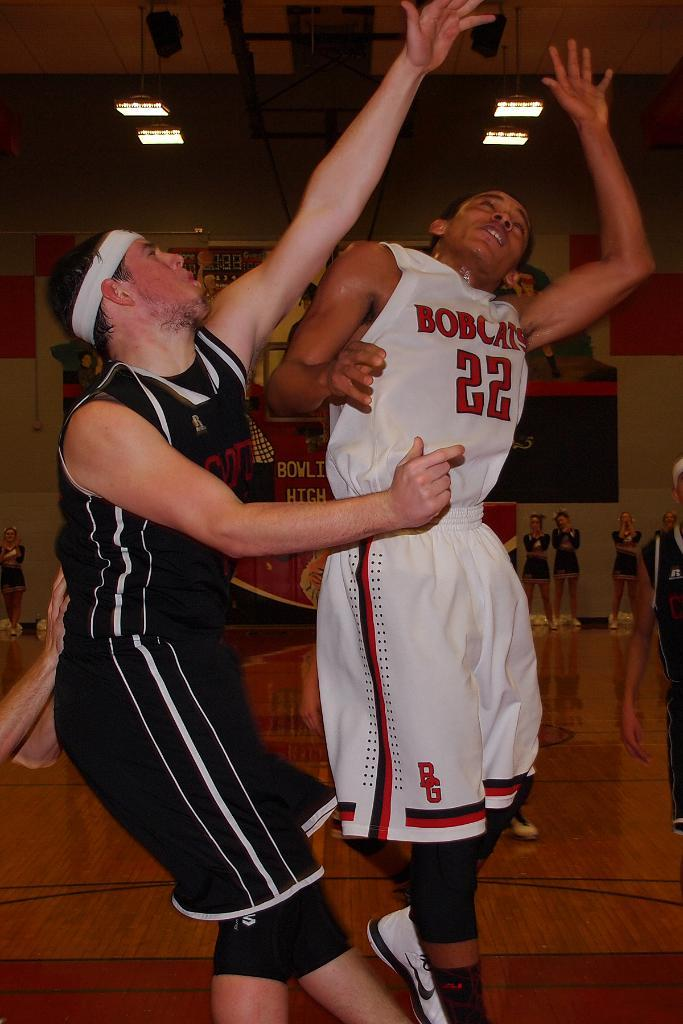Provide a one-sentence caption for the provided image. Player wearing number 22 for the Bobcats going for a rebound. 